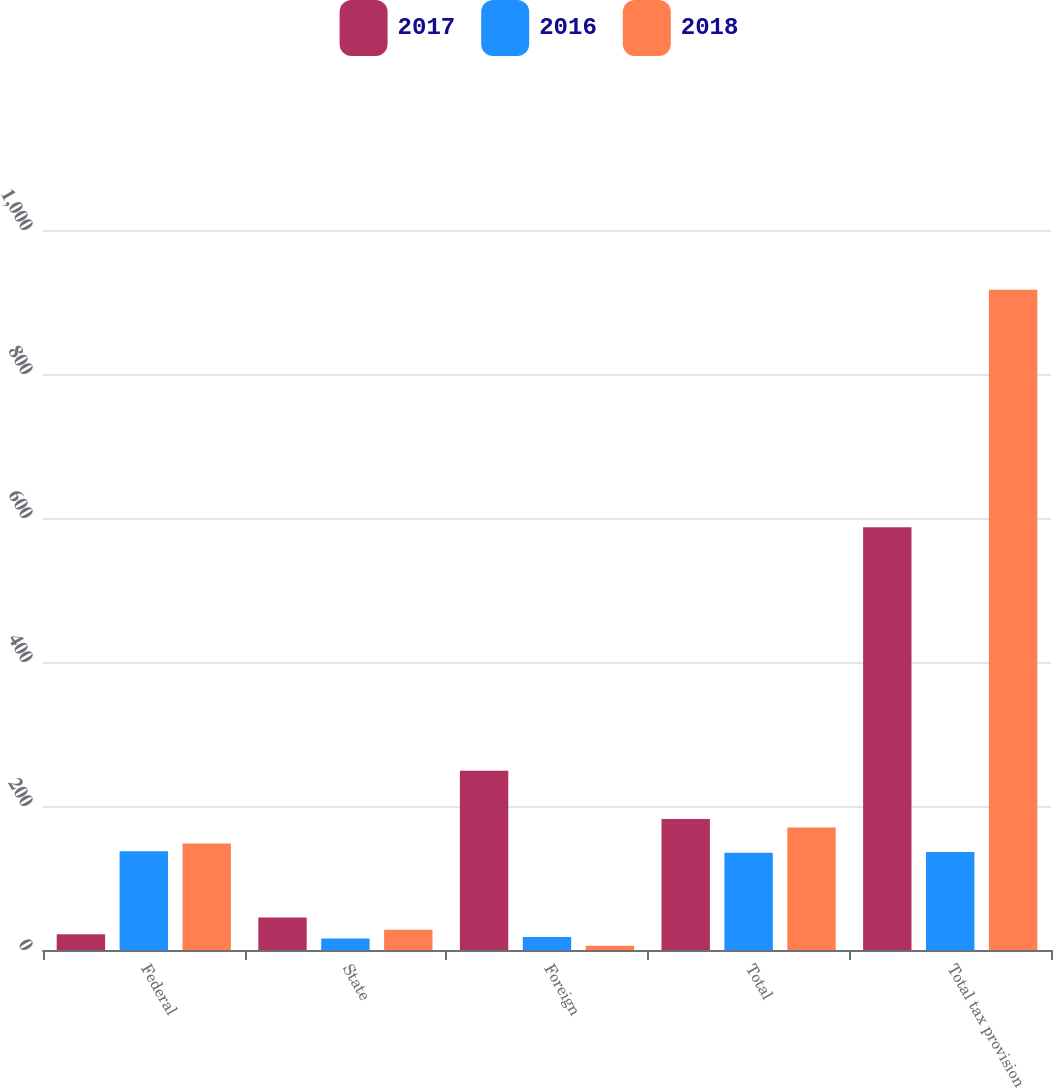<chart> <loc_0><loc_0><loc_500><loc_500><stacked_bar_chart><ecel><fcel>Federal<fcel>State<fcel>Foreign<fcel>Total<fcel>Total tax provision<nl><fcel>2017<fcel>22<fcel>45<fcel>249<fcel>182<fcel>587<nl><fcel>2016<fcel>137<fcel>16<fcel>18<fcel>135<fcel>136<nl><fcel>2018<fcel>148<fcel>28<fcel>6<fcel>170<fcel>917<nl></chart> 